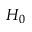Convert formula to latex. <formula><loc_0><loc_0><loc_500><loc_500>H _ { 0 }</formula> 